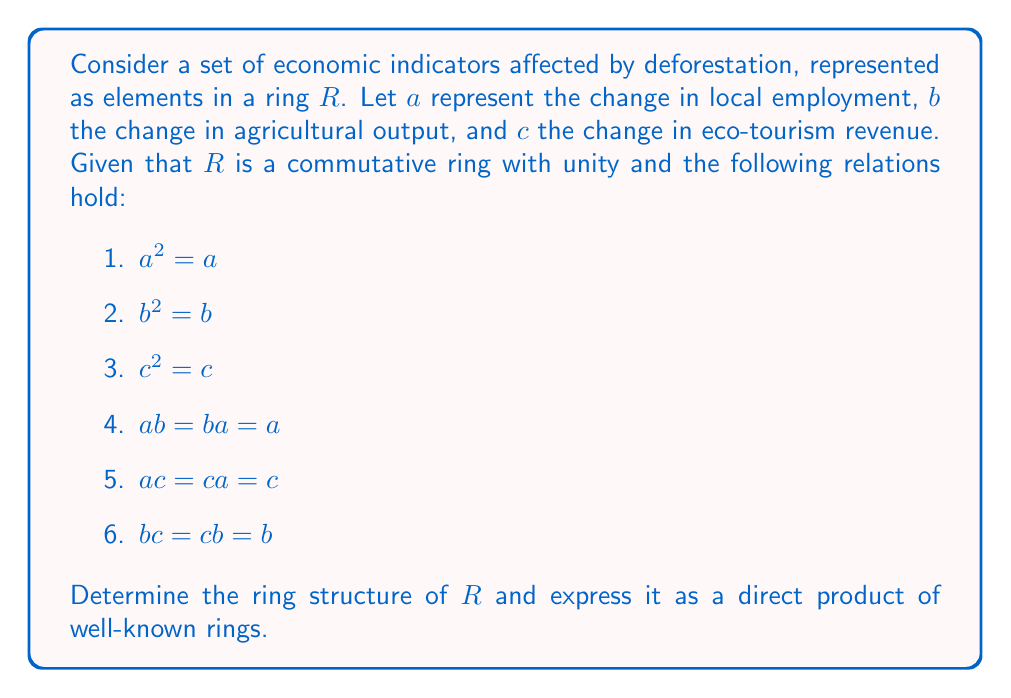Solve this math problem. To determine the ring structure of $R$, we'll follow these steps:

1) First, observe that $a$, $b$, and $c$ are idempotent elements (since $x^2 = x$ for each).

2) The relations given show that these elements are also orthogonal idempotents, meaning their pairwise products yield one of the elements.

3) In a commutative ring with unity, orthogonal idempotents that sum to 1 provide a decomposition of the ring into a direct product of rings.

4) Let's check if $a + b + c = 1$:
   $(a + b + c)^2 = a^2 + b^2 + c^2 + 2ab + 2ac + 2bc$
                  $= a + b + c + 2a + 2c + 2b$
                  $= 3(a + b + c)$

   This implies that either $a + b + c = 0$ or $a + b + c = 1$. Since these represent economic indicators, it's reasonable to assume they sum to 1.

5) Now, we can decompose $R$ into a direct product of three rings:
   $R \cong Ra \times Rb \times Rc$

6) Each of these component rings ($Ra$, $Rb$, $Rc$) is isomorphic to the field with two elements, $\mathbb{F}_2$, because each idempotent element can only be 0 or 1 in a ring.

Therefore, the ring structure of $R$ is isomorphic to the direct product of three copies of $\mathbb{F}_2$.
Answer: $R \cong \mathbb{F}_2 \times \mathbb{F}_2 \times \mathbb{F}_2$ 